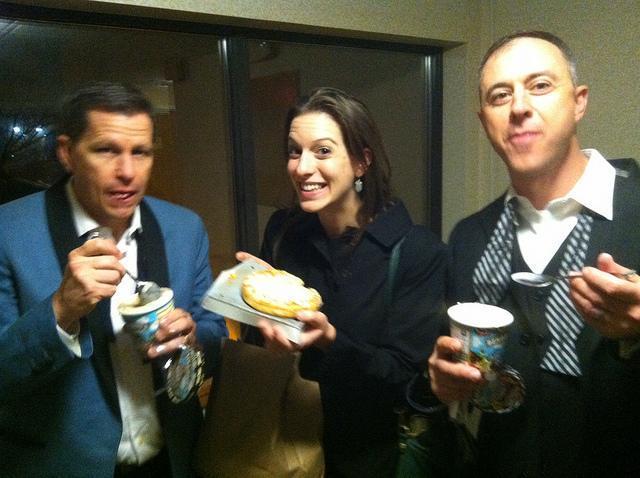How many screws do you see?
Give a very brief answer. 0. How many people are showing their teeth?
Give a very brief answer. 1. How many cups are in the picture?
Give a very brief answer. 2. How many people are visible?
Give a very brief answer. 3. How many cows are there?
Give a very brief answer. 0. 